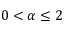Convert formula to latex. <formula><loc_0><loc_0><loc_500><loc_500>0 < \alpha \leq 2</formula> 